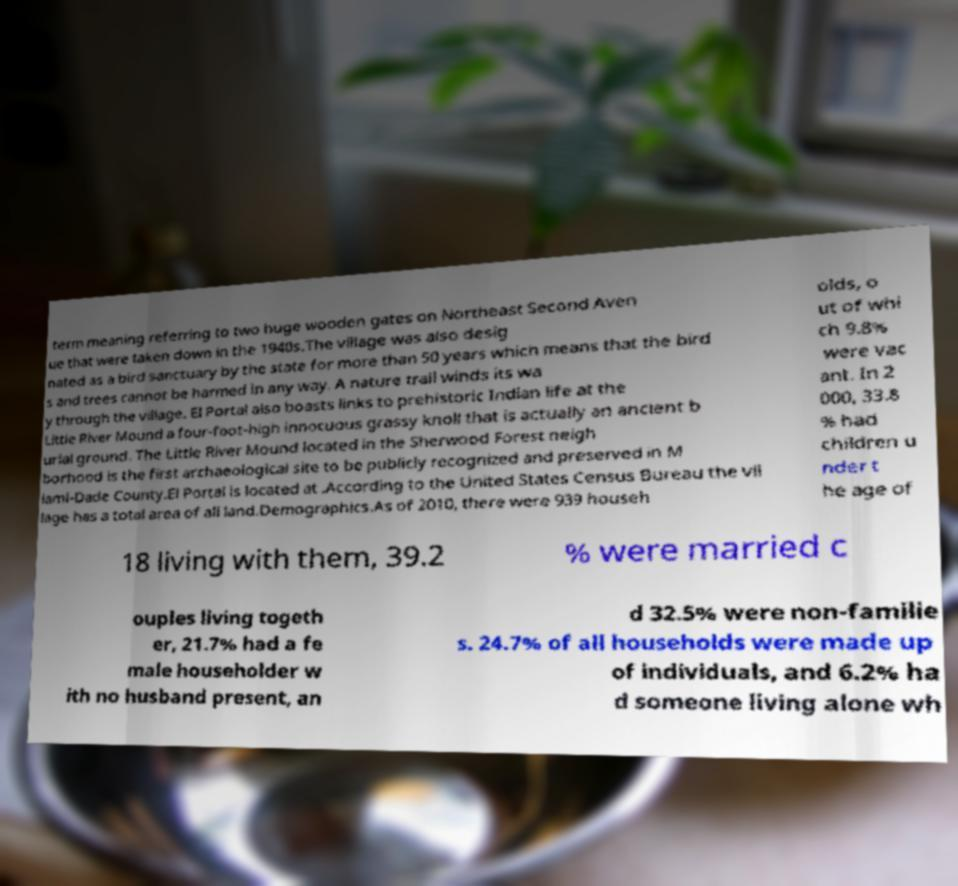There's text embedded in this image that I need extracted. Can you transcribe it verbatim? term meaning referring to two huge wooden gates on Northeast Second Aven ue that were taken down in the 1940s.The village was also desig nated as a bird sanctuary by the state for more than 50 years which means that the bird s and trees cannot be harmed in any way. A nature trail winds its wa y through the village. El Portal also boasts links to prehistoric Indian life at the Little River Mound a four-foot-high innocuous grassy knoll that is actually an ancient b urial ground. The Little River Mound located in the Sherwood Forest neigh borhood is the first archaeological site to be publicly recognized and preserved in M iami-Dade County.El Portal is located at .According to the United States Census Bureau the vil lage has a total area of all land.Demographics.As of 2010, there were 939 househ olds, o ut of whi ch 9.8% were vac ant. In 2 000, 33.8 % had children u nder t he age of 18 living with them, 39.2 % were married c ouples living togeth er, 21.7% had a fe male householder w ith no husband present, an d 32.5% were non-familie s. 24.7% of all households were made up of individuals, and 6.2% ha d someone living alone wh 